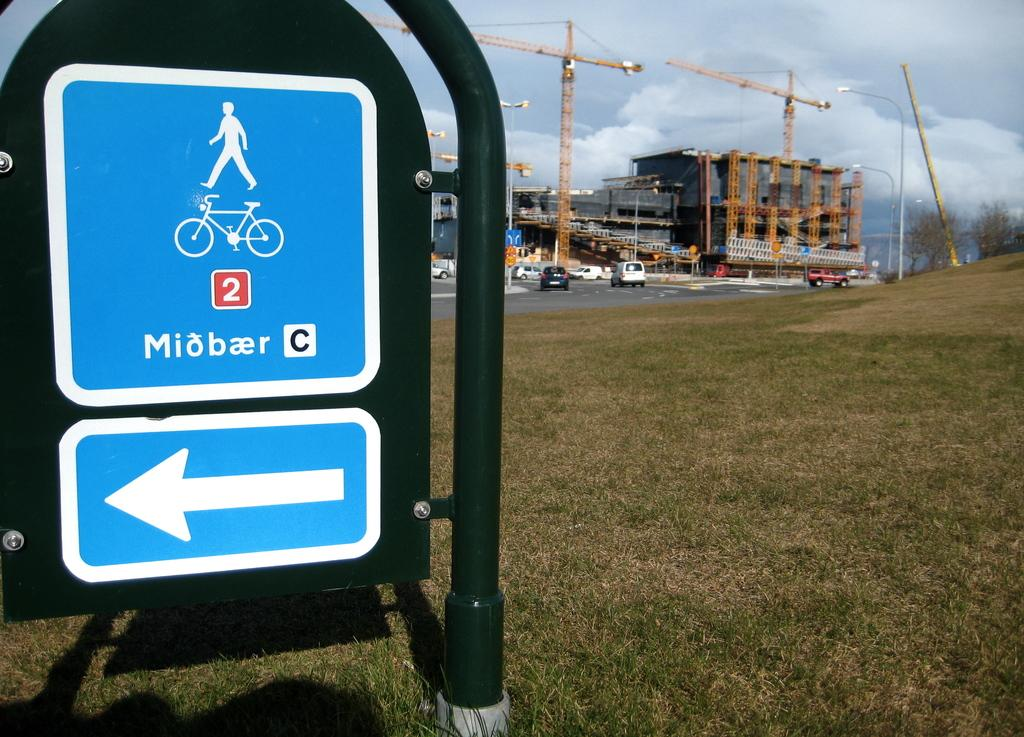<image>
Share a concise interpretation of the image provided. A blue and white sign that has a man on top and bicycle below. 